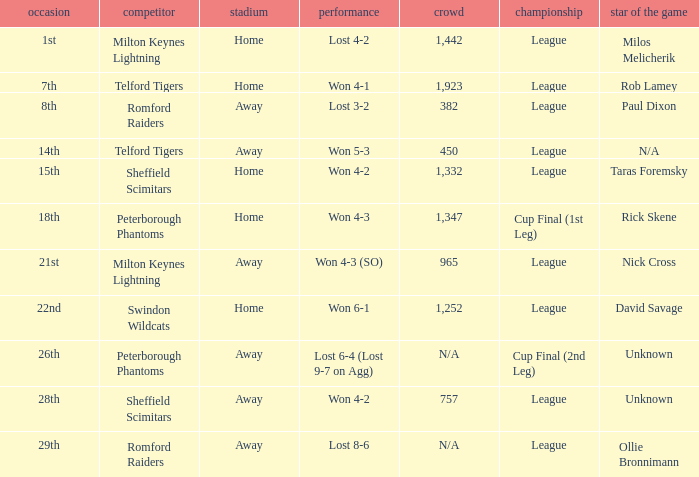What was the date when the attendance was n/a and the Man of the Match was unknown? 26th. 